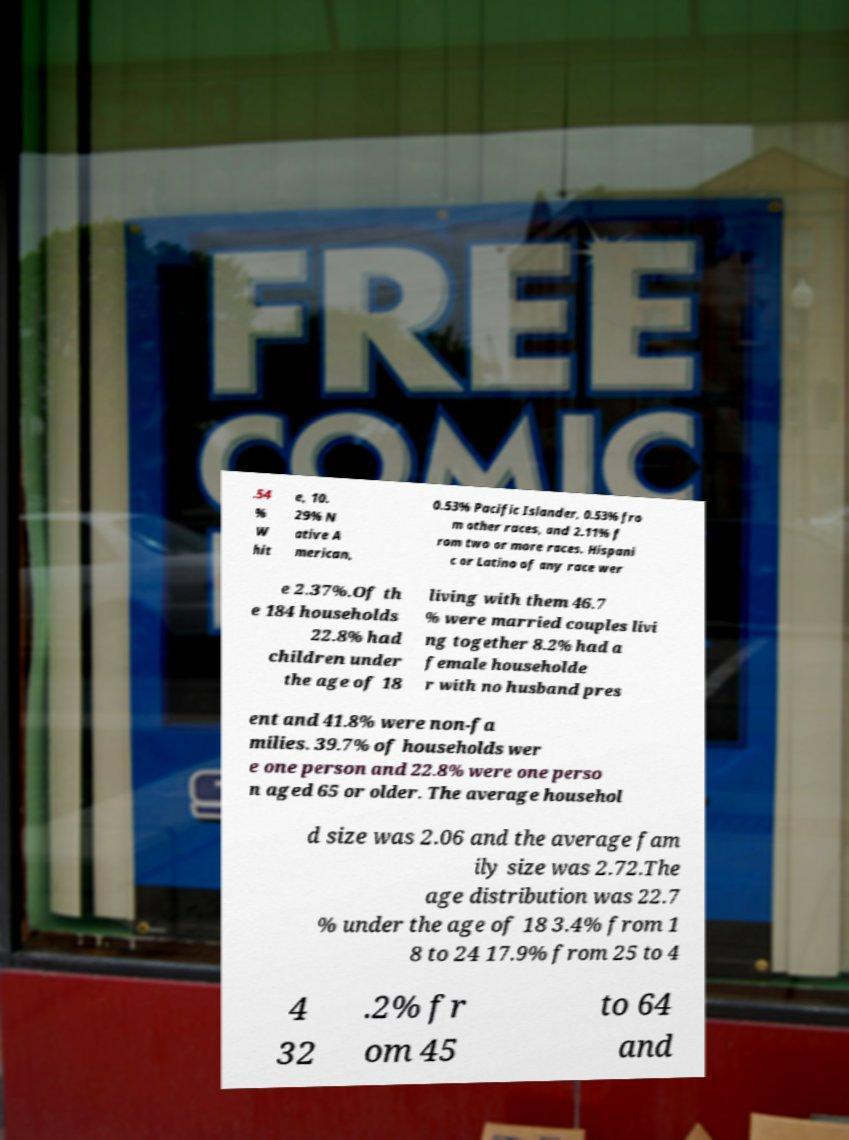Could you extract and type out the text from this image? .54 % W hit e, 10. 29% N ative A merican, 0.53% Pacific Islander, 0.53% fro m other races, and 2.11% f rom two or more races. Hispani c or Latino of any race wer e 2.37%.Of th e 184 households 22.8% had children under the age of 18 living with them 46.7 % were married couples livi ng together 8.2% had a female householde r with no husband pres ent and 41.8% were non-fa milies. 39.7% of households wer e one person and 22.8% were one perso n aged 65 or older. The average househol d size was 2.06 and the average fam ily size was 2.72.The age distribution was 22.7 % under the age of 18 3.4% from 1 8 to 24 17.9% from 25 to 4 4 32 .2% fr om 45 to 64 and 